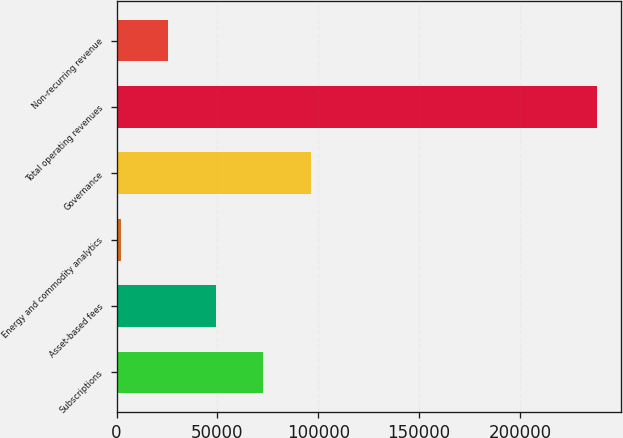Convert chart to OTSL. <chart><loc_0><loc_0><loc_500><loc_500><bar_chart><fcel>Subscriptions<fcel>Asset-based fees<fcel>Energy and commodity analytics<fcel>Governance<fcel>Total operating revenues<fcel>Non-recurring revenue<nl><fcel>72787.5<fcel>49180<fcel>1965<fcel>96395<fcel>238040<fcel>25572.5<nl></chart> 